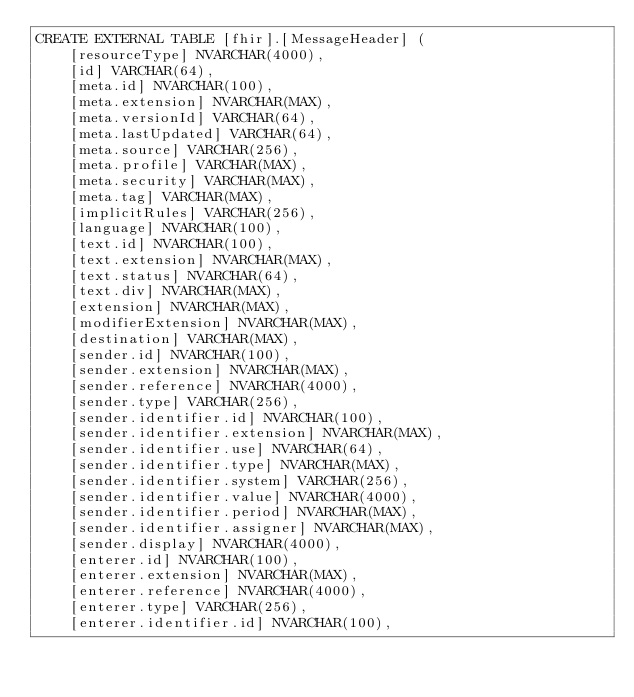Convert code to text. <code><loc_0><loc_0><loc_500><loc_500><_SQL_>CREATE EXTERNAL TABLE [fhir].[MessageHeader] (
    [resourceType] NVARCHAR(4000),
    [id] VARCHAR(64),
    [meta.id] NVARCHAR(100),
    [meta.extension] NVARCHAR(MAX),
    [meta.versionId] VARCHAR(64),
    [meta.lastUpdated] VARCHAR(64),
    [meta.source] VARCHAR(256),
    [meta.profile] VARCHAR(MAX),
    [meta.security] VARCHAR(MAX),
    [meta.tag] VARCHAR(MAX),
    [implicitRules] VARCHAR(256),
    [language] NVARCHAR(100),
    [text.id] NVARCHAR(100),
    [text.extension] NVARCHAR(MAX),
    [text.status] NVARCHAR(64),
    [text.div] NVARCHAR(MAX),
    [extension] NVARCHAR(MAX),
    [modifierExtension] NVARCHAR(MAX),
    [destination] VARCHAR(MAX),
    [sender.id] NVARCHAR(100),
    [sender.extension] NVARCHAR(MAX),
    [sender.reference] NVARCHAR(4000),
    [sender.type] VARCHAR(256),
    [sender.identifier.id] NVARCHAR(100),
    [sender.identifier.extension] NVARCHAR(MAX),
    [sender.identifier.use] NVARCHAR(64),
    [sender.identifier.type] NVARCHAR(MAX),
    [sender.identifier.system] VARCHAR(256),
    [sender.identifier.value] NVARCHAR(4000),
    [sender.identifier.period] NVARCHAR(MAX),
    [sender.identifier.assigner] NVARCHAR(MAX),
    [sender.display] NVARCHAR(4000),
    [enterer.id] NVARCHAR(100),
    [enterer.extension] NVARCHAR(MAX),
    [enterer.reference] NVARCHAR(4000),
    [enterer.type] VARCHAR(256),
    [enterer.identifier.id] NVARCHAR(100),</code> 